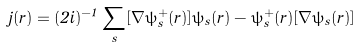Convert formula to latex. <formula><loc_0><loc_0><loc_500><loc_500>\hat { j } ( r ) = ( 2 i ) ^ { - 1 } \sum _ { s } [ \nabla \hat { \psi } _ { s } ^ { + } ( r ) ] \psi _ { s } ( r ) - \hat { \psi } _ { s } ^ { + } ( r ) [ \nabla \psi _ { s } ( r ) ]</formula> 